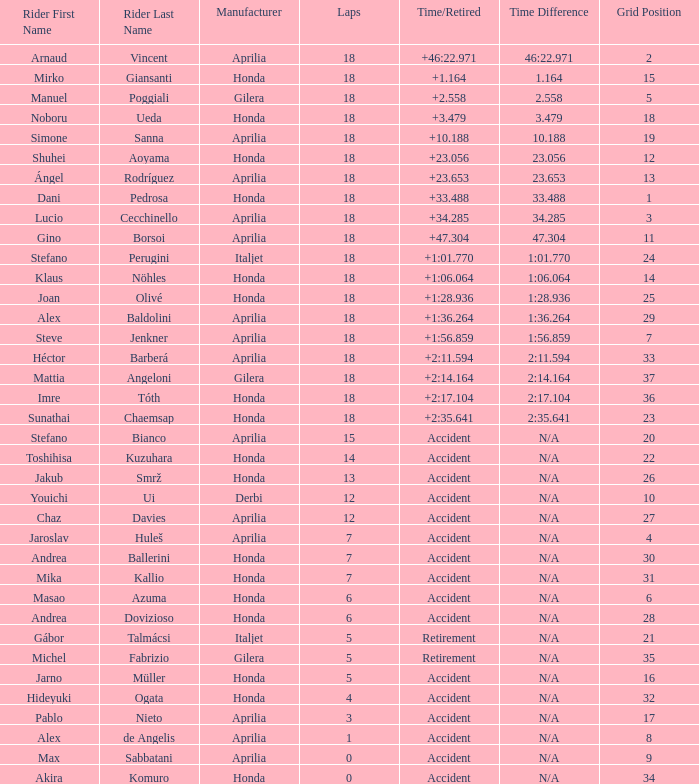When the grid has 27 positions and the manufacturer is aprilia, what is the average count of laps with incidents leading to retirement? 12.0. 